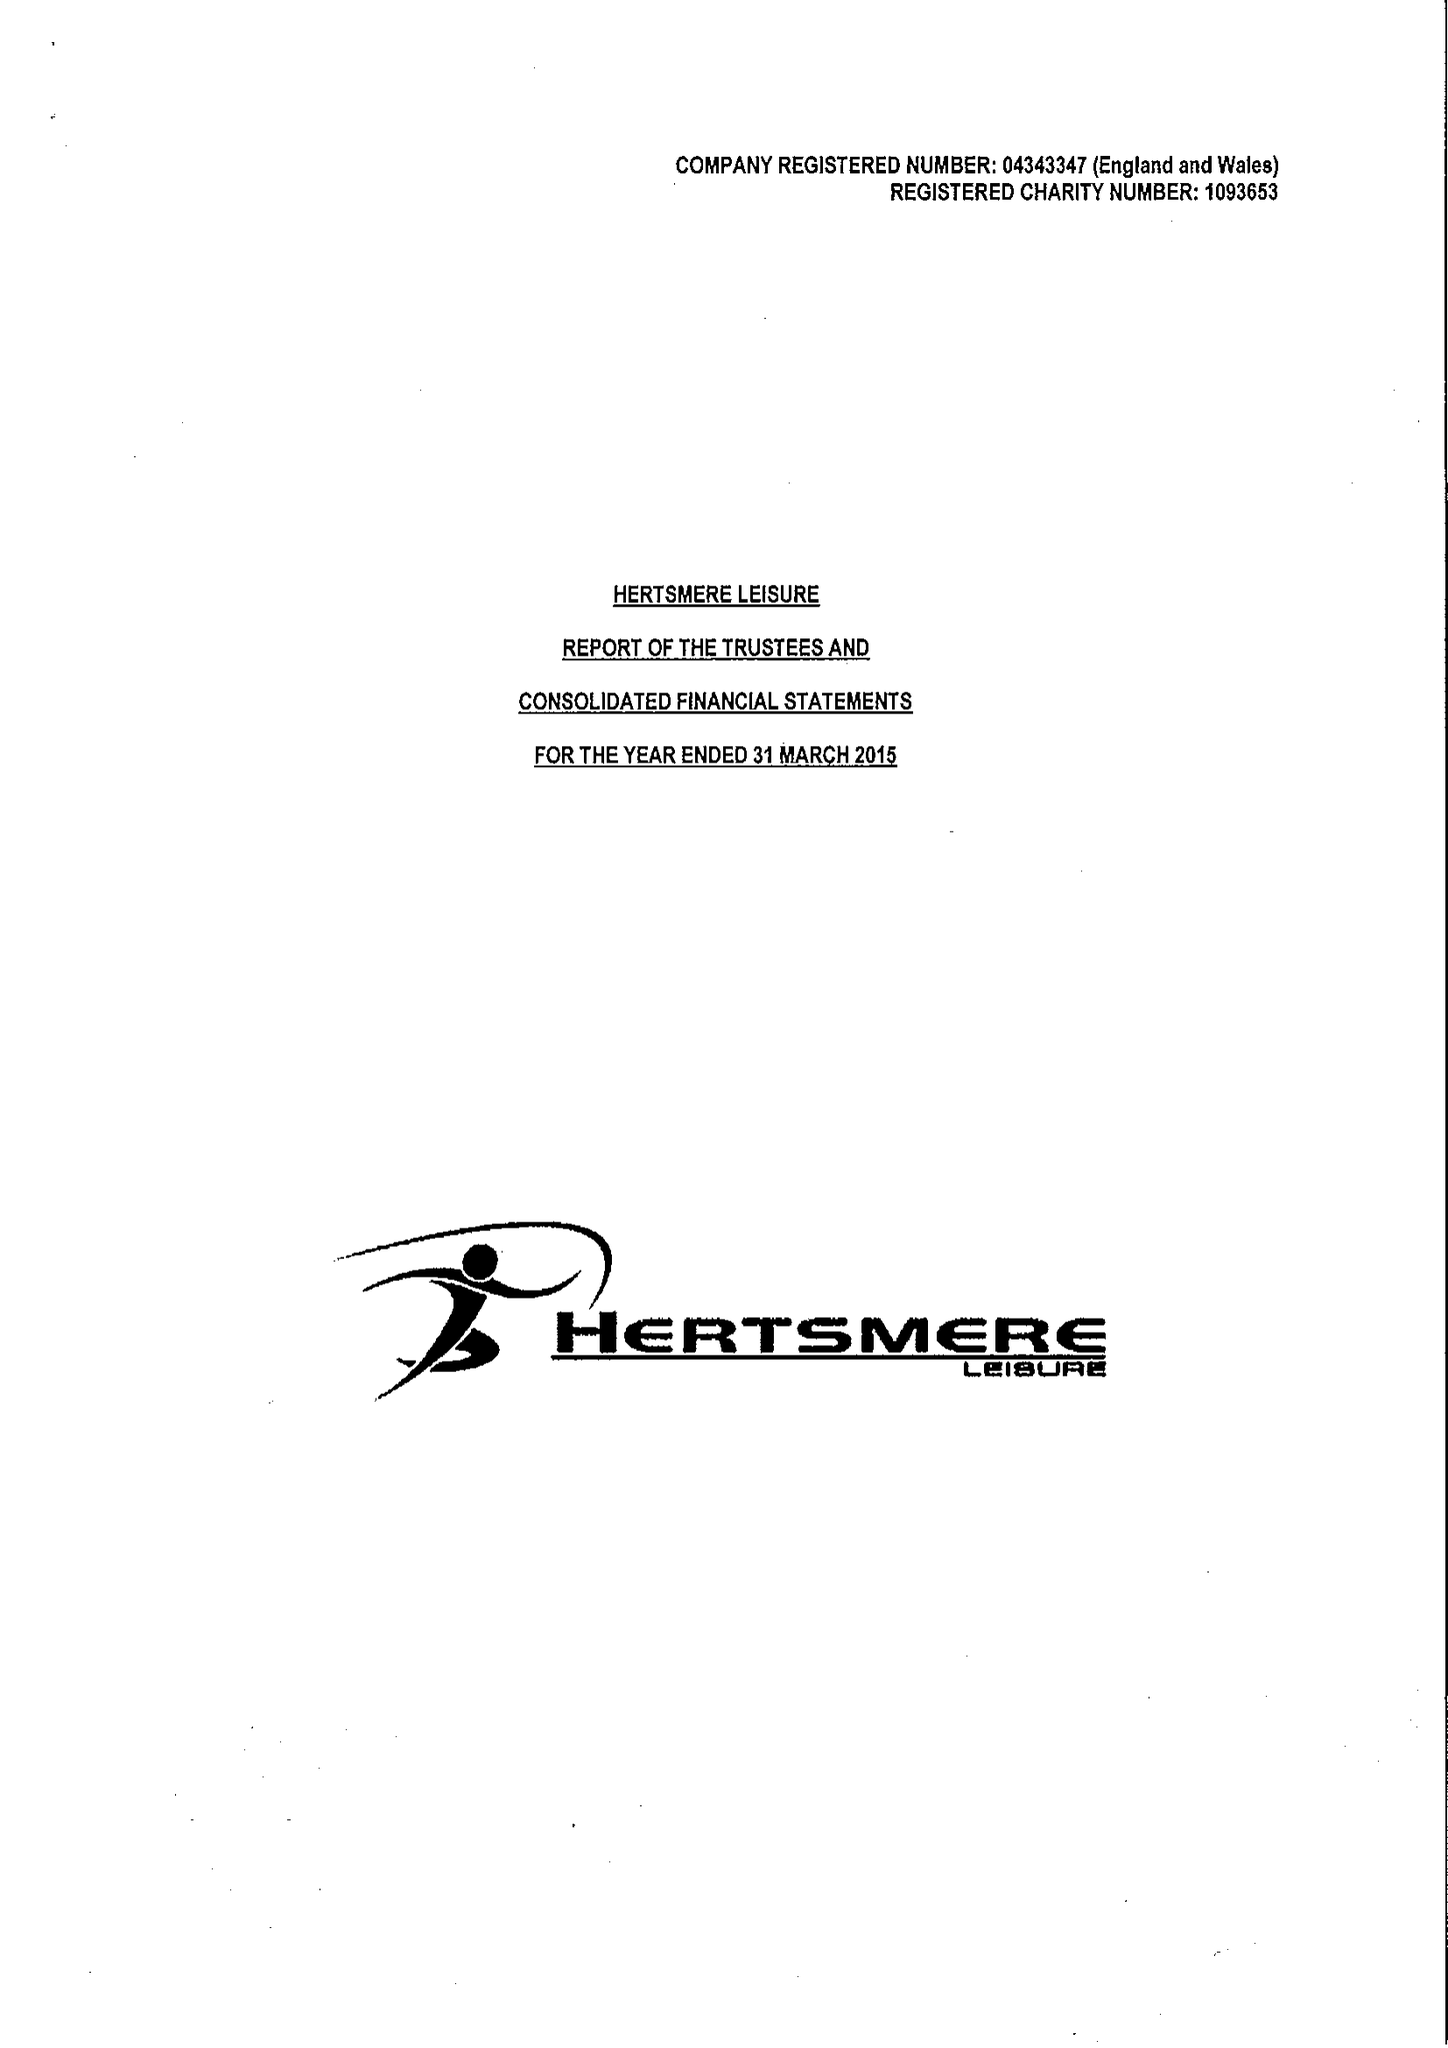What is the value for the charity_number?
Answer the question using a single word or phrase. 1093653 